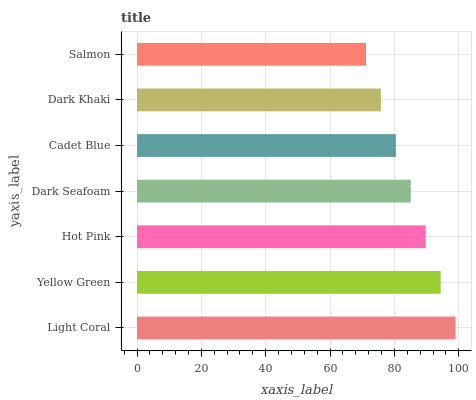Is Salmon the minimum?
Answer yes or no. Yes. Is Light Coral the maximum?
Answer yes or no. Yes. Is Yellow Green the minimum?
Answer yes or no. No. Is Yellow Green the maximum?
Answer yes or no. No. Is Light Coral greater than Yellow Green?
Answer yes or no. Yes. Is Yellow Green less than Light Coral?
Answer yes or no. Yes. Is Yellow Green greater than Light Coral?
Answer yes or no. No. Is Light Coral less than Yellow Green?
Answer yes or no. No. Is Dark Seafoam the high median?
Answer yes or no. Yes. Is Dark Seafoam the low median?
Answer yes or no. Yes. Is Dark Khaki the high median?
Answer yes or no. No. Is Yellow Green the low median?
Answer yes or no. No. 